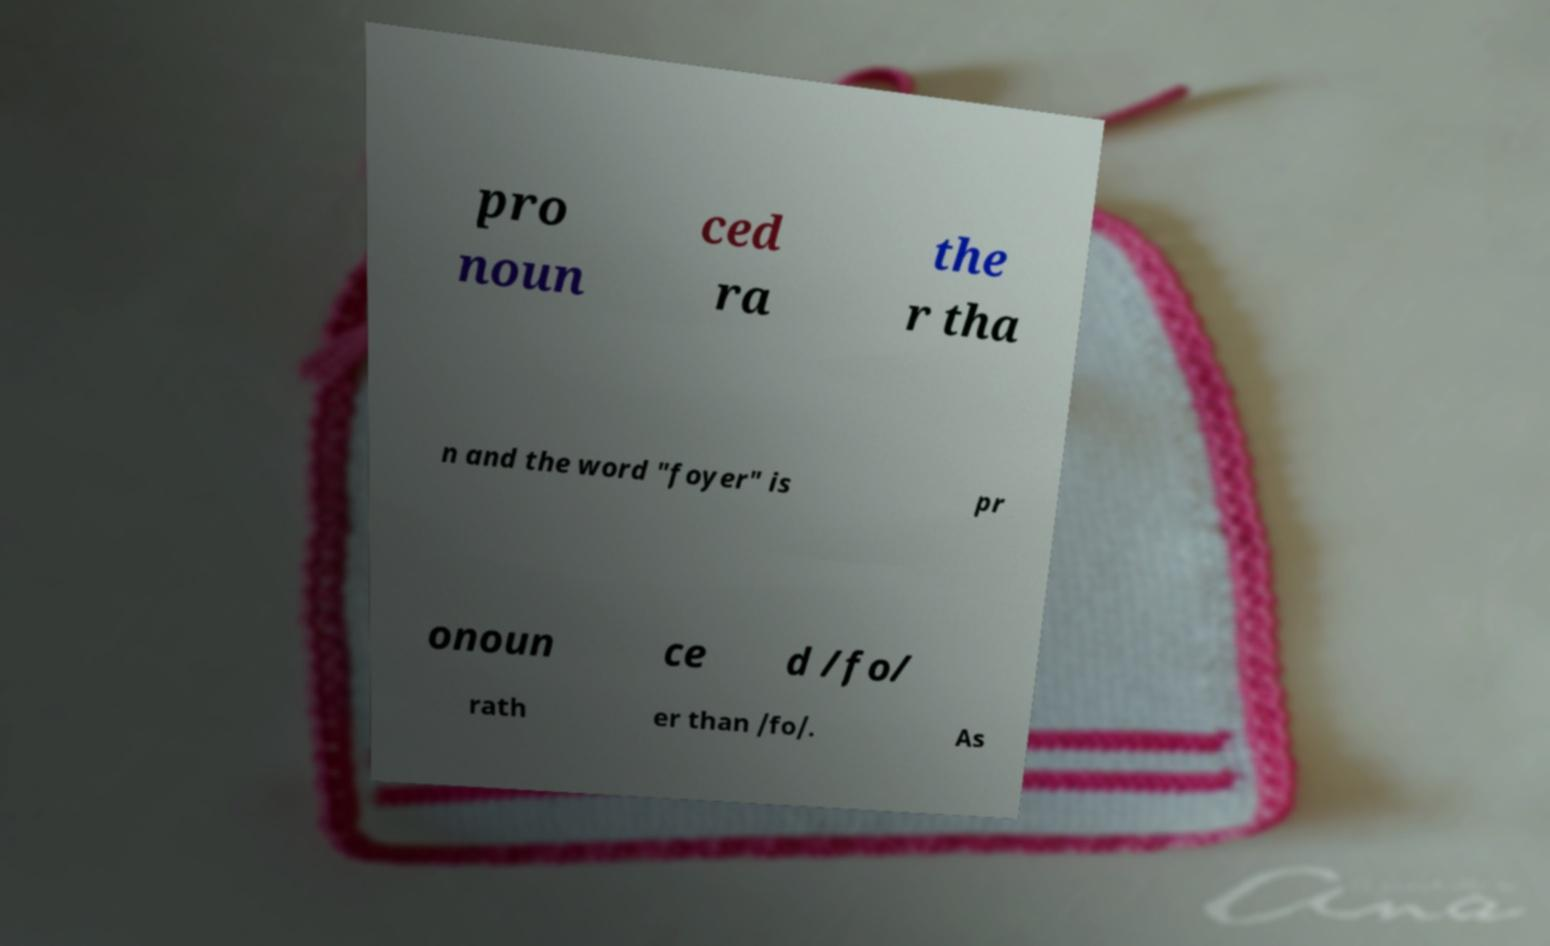What messages or text are displayed in this image? I need them in a readable, typed format. pro noun ced ra the r tha n and the word "foyer" is pr onoun ce d /fo/ rath er than /fo/. As 